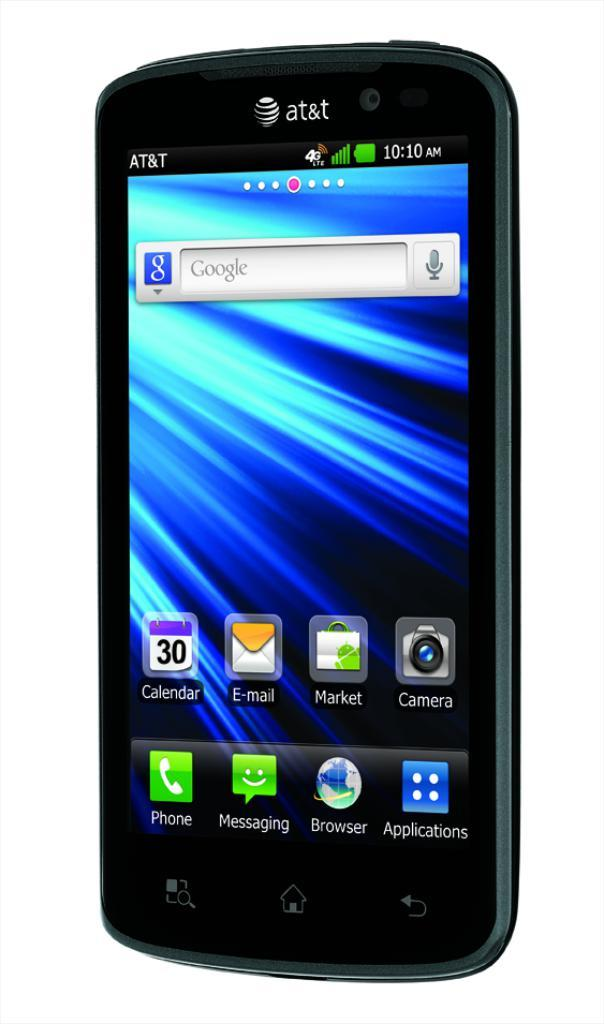<image>
Summarize the visual content of the image. A black AT&T phone has Calendar, E-mail, Market and Camera apps installed. 